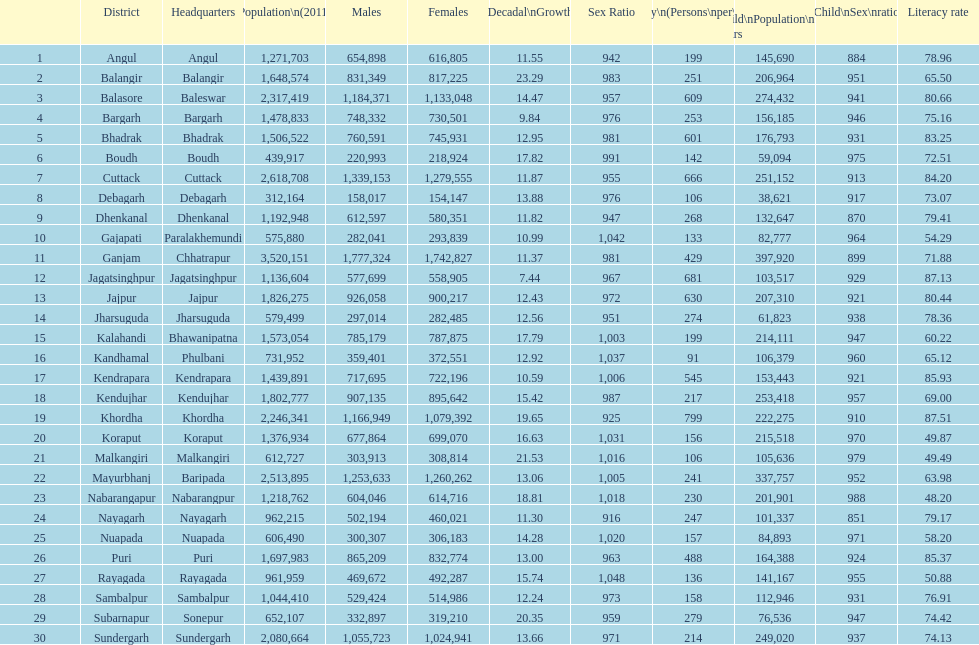Which district had least population growth from 2001-2011? Jagatsinghpur. 